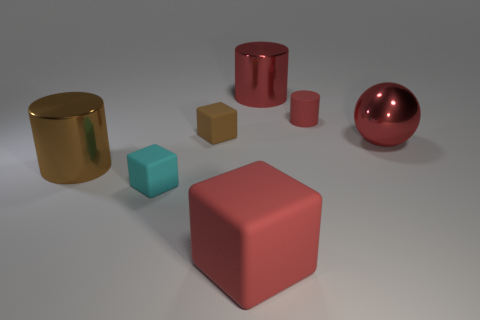The red metallic object that is the same shape as the large brown metal object is what size?
Offer a terse response. Large. The large object on the left side of the large thing in front of the cyan cube is what shape?
Provide a succinct answer. Cylinder. Is there any other thing that has the same size as the cyan cube?
Offer a very short reply. Yes. What shape is the red matte object that is in front of the large metallic cylinder in front of the metal object that is on the right side of the large red shiny cylinder?
Offer a very short reply. Cube. How many things are big red things in front of the shiny sphere or large red things behind the big red rubber block?
Provide a succinct answer. 3. There is a brown metallic object; does it have the same size as the object behind the small red matte thing?
Your answer should be very brief. Yes. Does the small brown block that is behind the tiny cyan rubber cube have the same material as the big cylinder right of the big brown metallic cylinder?
Make the answer very short. No. Are there an equal number of big matte things on the right side of the small brown matte thing and big brown things to the right of the big red metal sphere?
Make the answer very short. No. How many big matte things have the same color as the ball?
Keep it short and to the point. 1. What is the material of the tiny cylinder that is the same color as the large metallic ball?
Ensure brevity in your answer.  Rubber. 